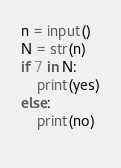Convert code to text. <code><loc_0><loc_0><loc_500><loc_500><_Python_>n = input()
N = str(n)
if 7 in N:
    print(yes)
else:
    print(no)
    </code> 